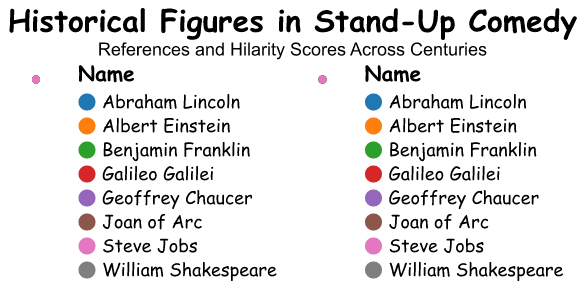What is the title of the figure? The title of the figure is usually positioned at the top and provides a summary of what the plot represents. In this case, the title is "Historical Figures in Stand-Up Comedy," along with the subtitle "References and Hilarity Scores Across Centuries."
Answer: Historical Figures in Stand-Up Comedy Which historical figure from the 19th century has the highest hilarity score? Referring to the visual representation, the 19th-century historical figure shown with the highest hilarity score is Abraham Lincoln, with a hilarity score of 4.9.
Answer: Abraham Lincoln Which century has the fewest references to historical figures in stand-up comedy acts? By looking at the "References" subplot, it is clear from the radial axis which century has the smallest value. The 14th century, representing Geoffrey Chaucer, has only 5 references, which are fewer than any other century mentioned.
Answer: 14th century What is the average hilarity score of the historical figures from the 20th and 21st centuries? The hilarity scores for the 20th century (Albert Einstein) and 21st century (Steve Jobs) are 4.7 and 4.3, respectively. To find the average, we add these scores together and divide by 2: (4.7 + 4.3) / 2 = 4.5.
Answer: 4.5 Who has more references, Joan of Arc or Willie Shakespeare? Referring to the plot, count the reference points for Joan of Arc (8) and William Shakespeare (15). William Shakespeare has more references than Joan of Arc.
Answer: William Shakespeare Which comedic style is associated with Benjamin Franklin and how many references does he have? Benjamin Franklin's comedic style is displayed as 'Sarcasm,' and his number of references is indicated to be 10.
Answer: Sarcasm, 10 How do stand-up comedians rate the hilarity of Galileo Galilei compared to that of Joan of Arc? Comparing the hilarity scores for Galileo Galilei and Joan of Arc on the "Hilarity Score" subplot, we find that Galileo has a score of 4.0 while Joan of Arc has a score of 4.2. Therefore, Joan of Arc is rated higher in hilarity.
Answer: Joan of Arc is rated higher What's the sum of all the references for historical figures from the 16th century and 18th century? The references for William Shakespeare (16th century) and Benjamin Franklin (18th century) are 15 and 10 respectively. Summing them up: 15 + 10 = 25.
Answer: 25 Which historical figure has a higher hilarity score, Steve Jobs or Albert Einstein? Examining the "Hilarity Score" subplot, Steve Jobs has a hilarity score of 4.3 whereas Albert Einstein has a hilarity score of 4.7. Thus, Albert Einstein has a higher hilarity score.
Answer: Albert Einstein 